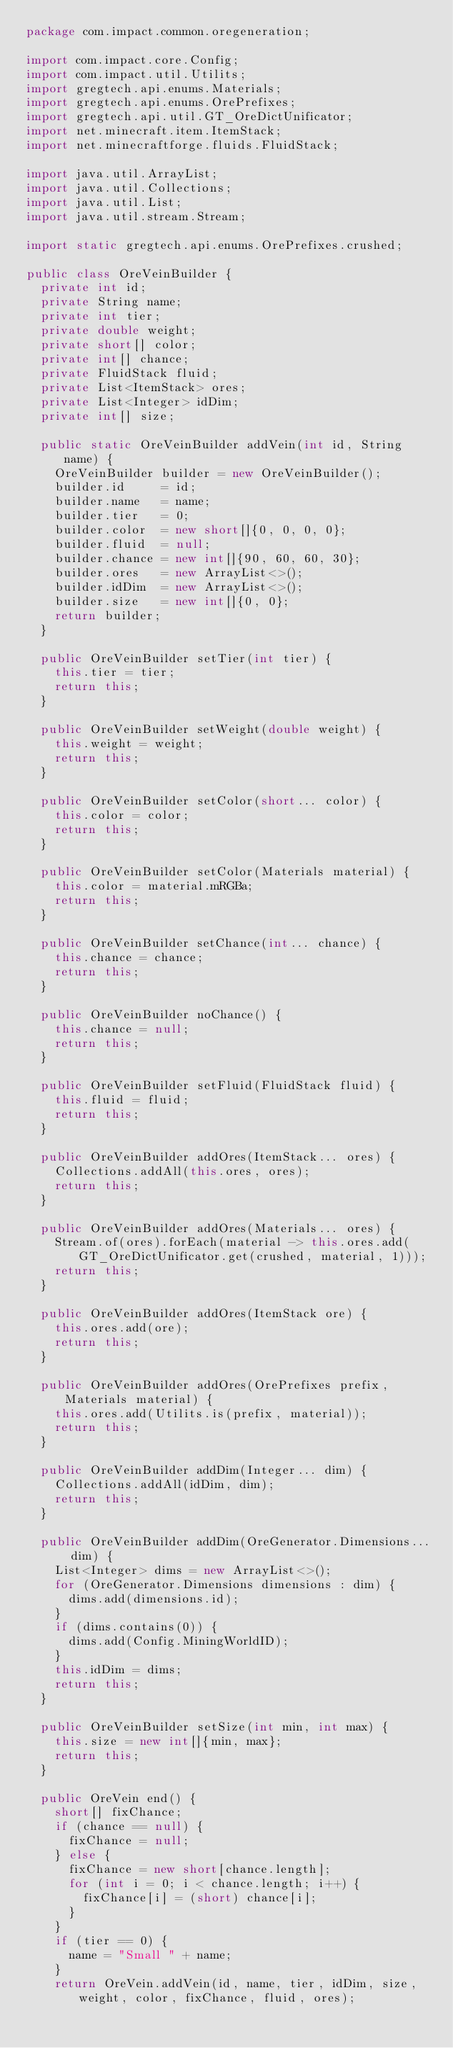<code> <loc_0><loc_0><loc_500><loc_500><_Java_>package com.impact.common.oregeneration;

import com.impact.core.Config;
import com.impact.util.Utilits;
import gregtech.api.enums.Materials;
import gregtech.api.enums.OrePrefixes;
import gregtech.api.util.GT_OreDictUnificator;
import net.minecraft.item.ItemStack;
import net.minecraftforge.fluids.FluidStack;

import java.util.ArrayList;
import java.util.Collections;
import java.util.List;
import java.util.stream.Stream;

import static gregtech.api.enums.OrePrefixes.crushed;

public class OreVeinBuilder {
	private int id;
	private String name;
	private int tier;
	private double weight;
	private short[] color;
	private int[] chance;
	private FluidStack fluid;
	private List<ItemStack> ores;
	private List<Integer> idDim;
	private int[] size;
	
	public static OreVeinBuilder addVein(int id, String name) {
		OreVeinBuilder builder = new OreVeinBuilder();
		builder.id     = id;
		builder.name   = name;
		builder.tier   = 0;
		builder.color  = new short[]{0, 0, 0, 0};
		builder.fluid  = null;
		builder.chance = new int[]{90, 60, 60, 30};
		builder.ores   = new ArrayList<>();
		builder.idDim  = new ArrayList<>();
		builder.size   = new int[]{0, 0};
		return builder;
	}
	
	public OreVeinBuilder setTier(int tier) {
		this.tier = tier;
		return this;
	}
	
	public OreVeinBuilder setWeight(double weight) {
		this.weight = weight;
		return this;
	}
	
	public OreVeinBuilder setColor(short... color) {
		this.color = color;
		return this;
	}
	
	public OreVeinBuilder setColor(Materials material) {
		this.color = material.mRGBa;
		return this;
	}
	
	public OreVeinBuilder setChance(int... chance) {
		this.chance = chance;
		return this;
	}
	
	public OreVeinBuilder noChance() {
		this.chance = null;
		return this;
	}
	
	public OreVeinBuilder setFluid(FluidStack fluid) {
		this.fluid = fluid;
		return this;
	}
	
	public OreVeinBuilder addOres(ItemStack... ores) {
		Collections.addAll(this.ores, ores);
		return this;
	}
	
	public OreVeinBuilder addOres(Materials... ores) {
		Stream.of(ores).forEach(material -> this.ores.add(GT_OreDictUnificator.get(crushed, material, 1)));
		return this;
	}
	
	public OreVeinBuilder addOres(ItemStack ore) {
		this.ores.add(ore);
		return this;
	}
	
	public OreVeinBuilder addOres(OrePrefixes prefix, Materials material) {
		this.ores.add(Utilits.is(prefix, material));
		return this;
	}
	
	public OreVeinBuilder addDim(Integer... dim) {
		Collections.addAll(idDim, dim);
		return this;
	}
	
	public OreVeinBuilder addDim(OreGenerator.Dimensions... dim) {
		List<Integer> dims = new ArrayList<>();
		for (OreGenerator.Dimensions dimensions : dim) {
			dims.add(dimensions.id);
		}
		if (dims.contains(0)) {
			dims.add(Config.MiningWorldID);
		}
		this.idDim = dims;
		return this;
	}
	
	public OreVeinBuilder setSize(int min, int max) {
		this.size = new int[]{min, max};
		return this;
	}
	
	public OreVein end() {
		short[] fixChance;
		if (chance == null) {
			fixChance = null;
		} else {
			fixChance = new short[chance.length];
			for (int i = 0; i < chance.length; i++) {
				fixChance[i] = (short) chance[i];
			}
		}
		if (tier == 0) {
			name = "Small " + name;
		}
		return OreVein.addVein(id, name, tier, idDim, size, weight, color, fixChance, fluid, ores);</code> 